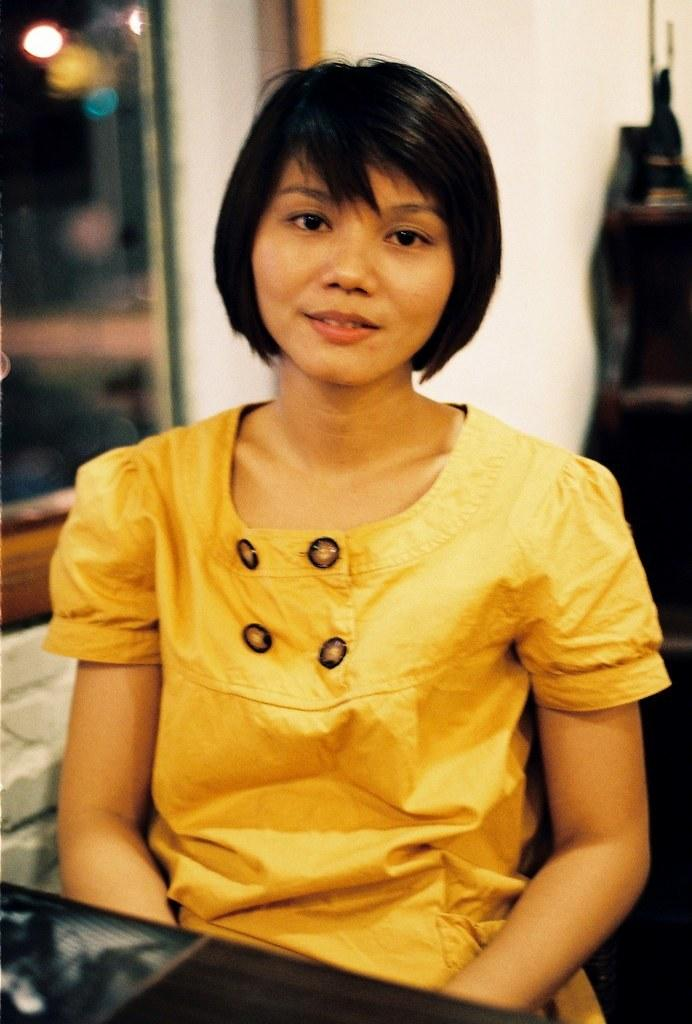Who is the main subject in the image? There is a lady sitting in the center of the image. What is located at the bottom of the image? There is a table at the bottom of the image. What can be seen in the background of the image? There is a wall in the background of the image, and there is also a window visible. What type of meat is being sold in the shop visible through the window? There is no shop visible through the window in the image, and therefore no meat can be seen being sold. 